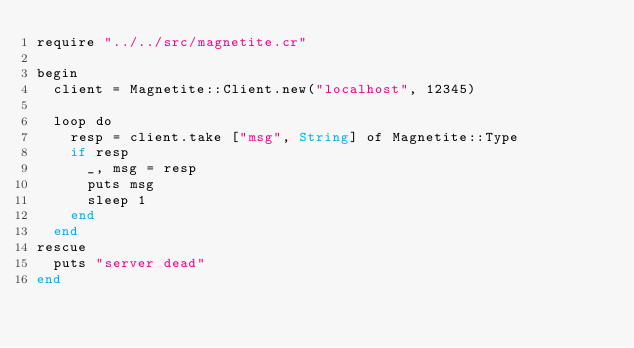Convert code to text. <code><loc_0><loc_0><loc_500><loc_500><_Crystal_>require "../../src/magnetite.cr"

begin
  client = Magnetite::Client.new("localhost", 12345)

  loop do
    resp = client.take ["msg", String] of Magnetite::Type
    if resp
      _, msg = resp
      puts msg
      sleep 1
    end
  end
rescue
  puts "server dead"
end
</code> 